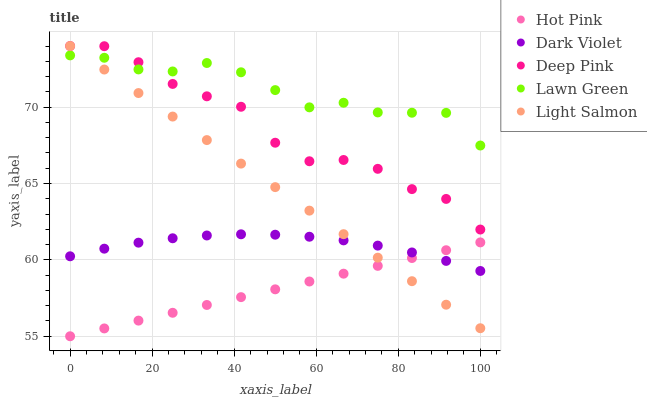Does Hot Pink have the minimum area under the curve?
Answer yes or no. Yes. Does Lawn Green have the maximum area under the curve?
Answer yes or no. Yes. Does Light Salmon have the minimum area under the curve?
Answer yes or no. No. Does Light Salmon have the maximum area under the curve?
Answer yes or no. No. Is Hot Pink the smoothest?
Answer yes or no. Yes. Is Deep Pink the roughest?
Answer yes or no. Yes. Is Light Salmon the smoothest?
Answer yes or no. No. Is Light Salmon the roughest?
Answer yes or no. No. Does Hot Pink have the lowest value?
Answer yes or no. Yes. Does Light Salmon have the lowest value?
Answer yes or no. No. Does Deep Pink have the highest value?
Answer yes or no. Yes. Does Hot Pink have the highest value?
Answer yes or no. No. Is Hot Pink less than Deep Pink?
Answer yes or no. Yes. Is Deep Pink greater than Dark Violet?
Answer yes or no. Yes. Does Lawn Green intersect Light Salmon?
Answer yes or no. Yes. Is Lawn Green less than Light Salmon?
Answer yes or no. No. Is Lawn Green greater than Light Salmon?
Answer yes or no. No. Does Hot Pink intersect Deep Pink?
Answer yes or no. No. 